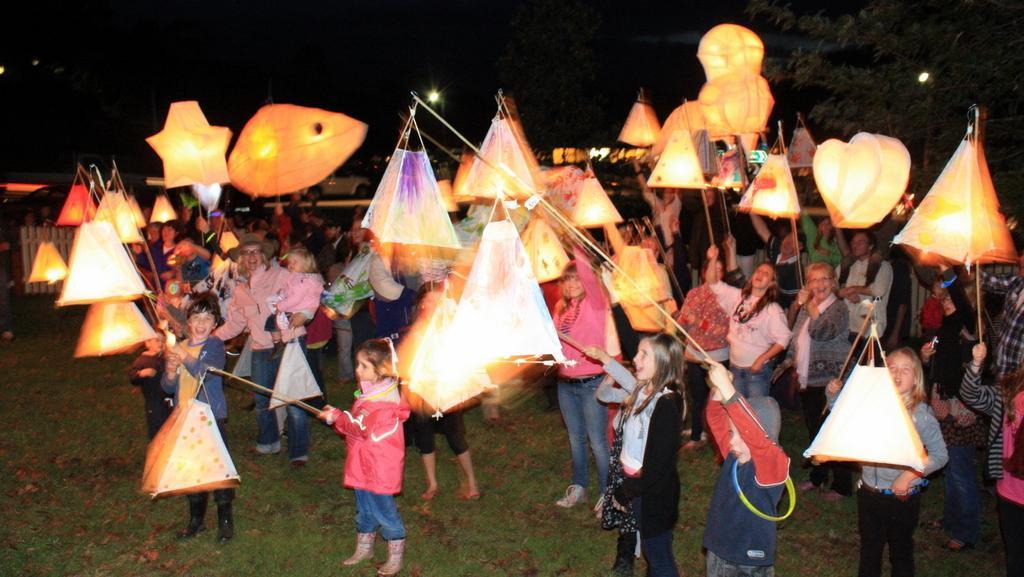Describe this image in one or two sentences. This is an image clicked in the dark. Here I can see few people are standing in the ground and flying the sky lanterns into the air. On the the right top of the image there is a tree and I can see some lights. 